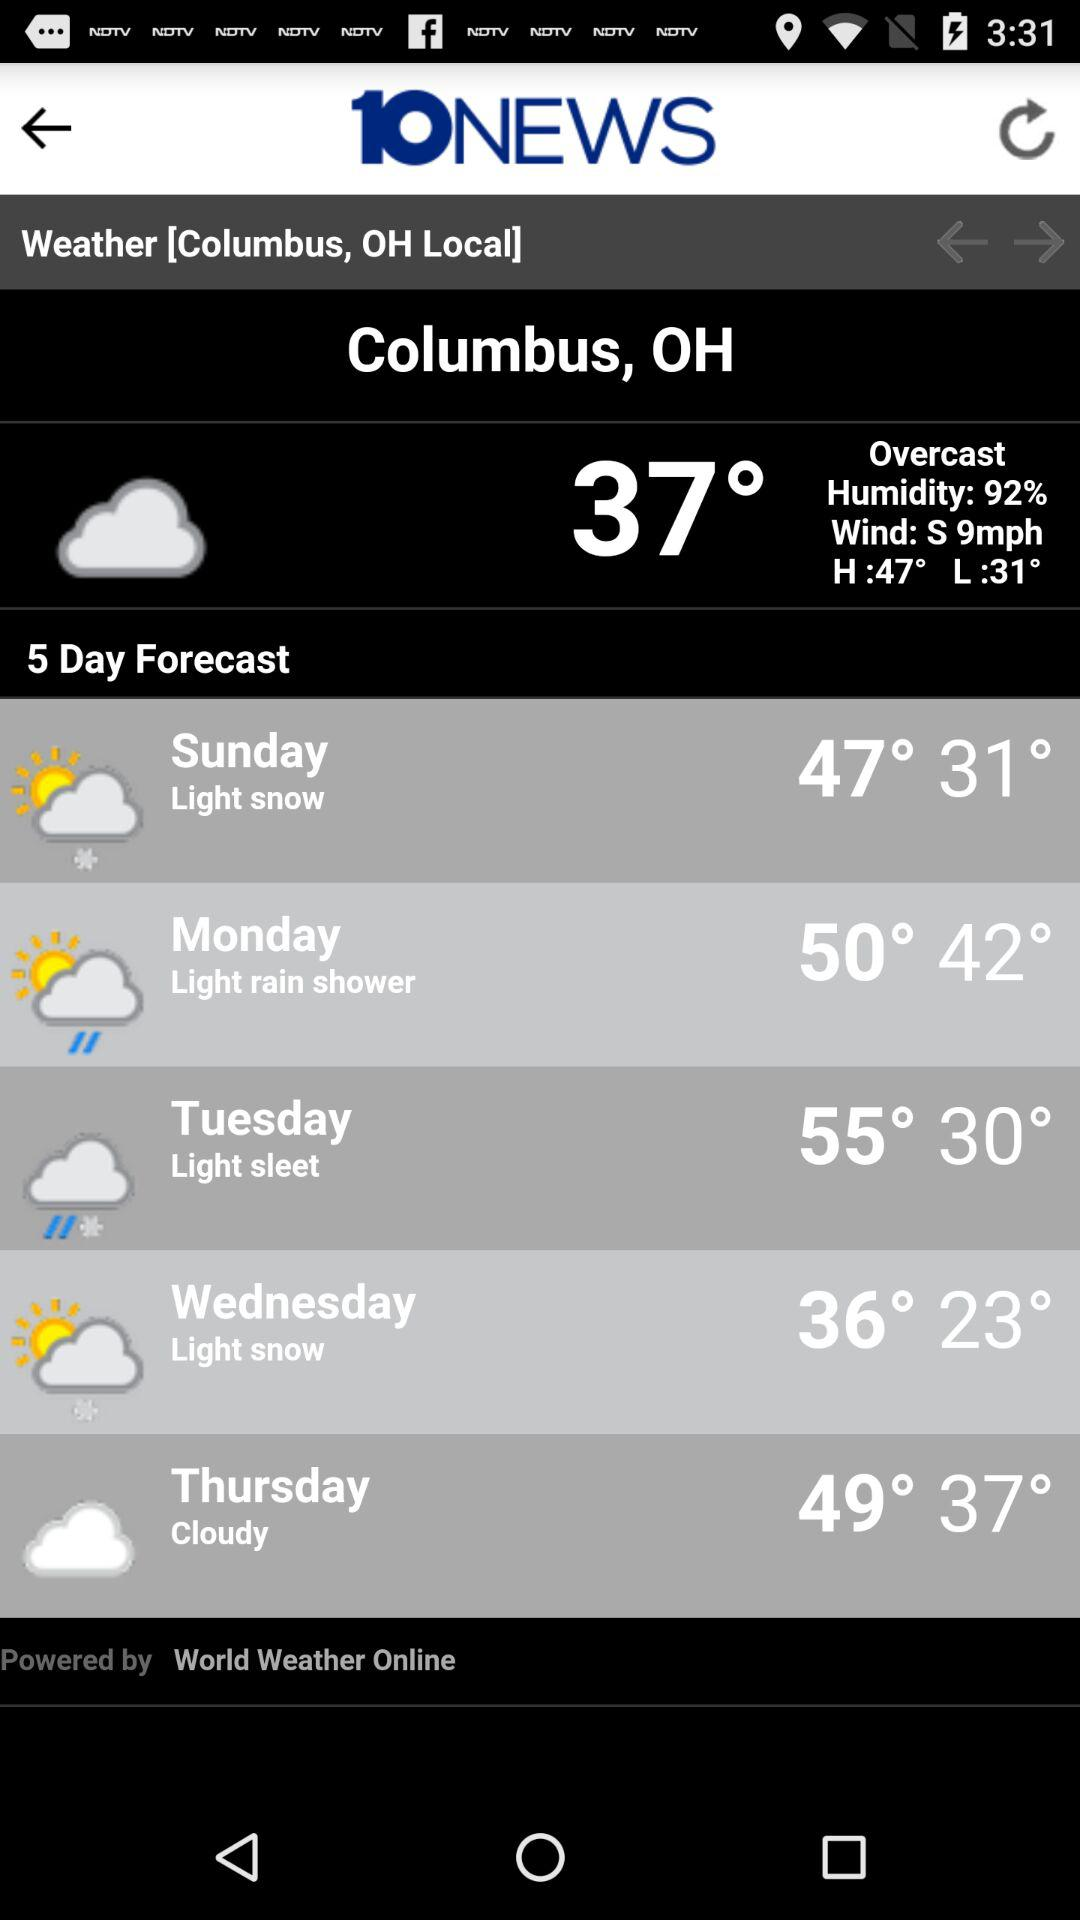What is the highest temperature on Tuesday? The highest temperature on Tuesday is 55°. 